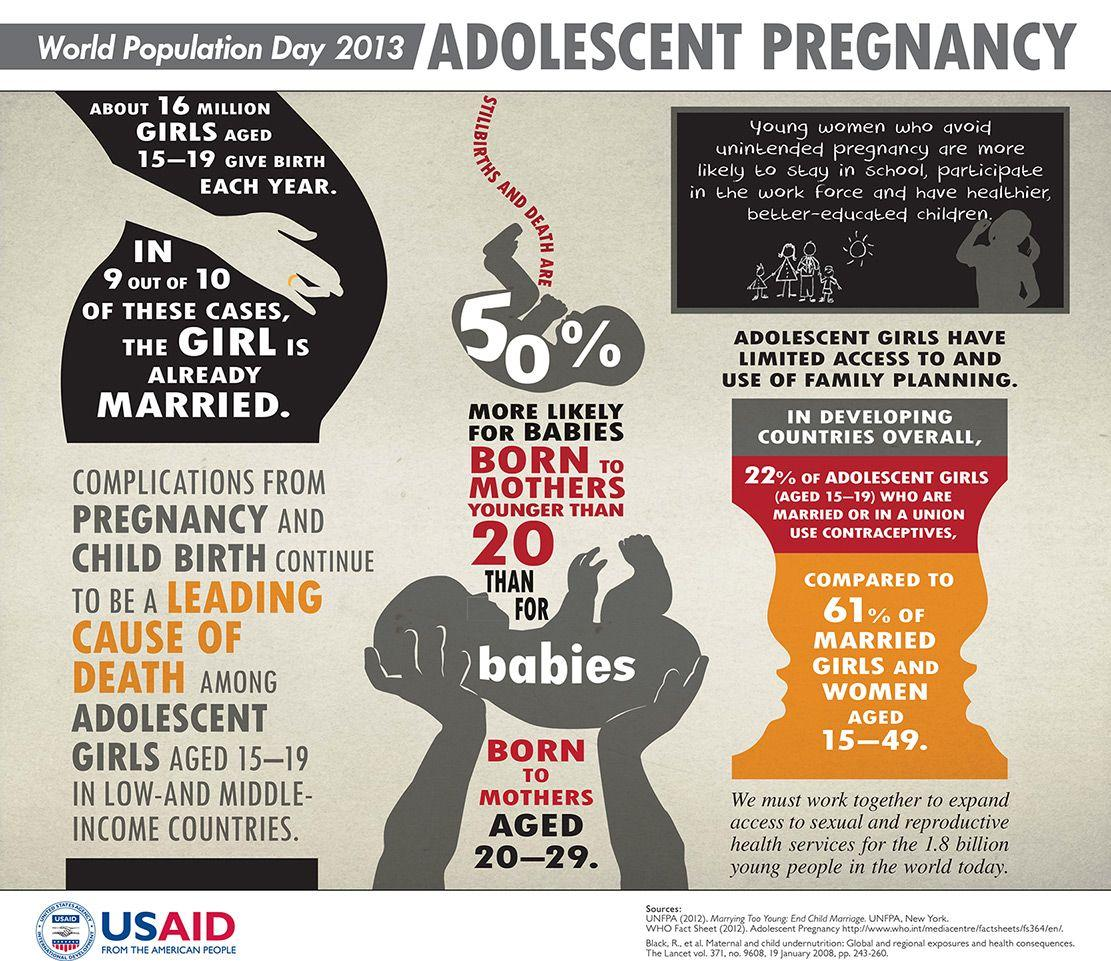Give some essential details in this illustration. Approximately 50% of stillbirths and deaths occur each year. A staggering 78% of adolescent girls who are married or in a union do not use contraceptives, highlighting the need for increased access to education and reproductive health services for young women. In the United States, approximately 4 million babies are born each year, and of those births, it is estimated that 25% of the mothers are not married. 